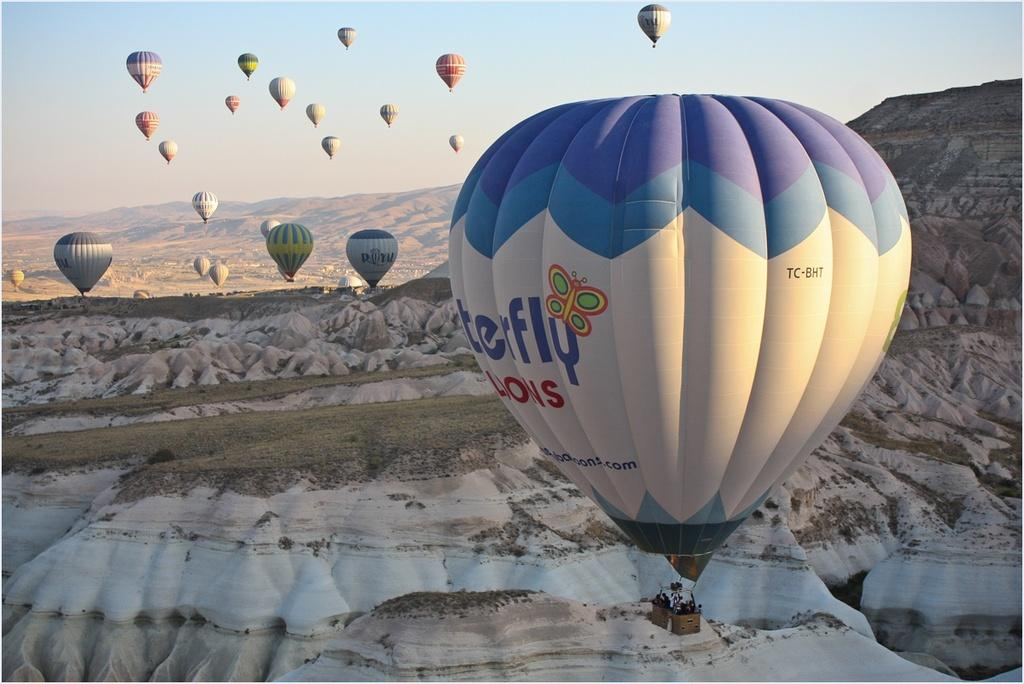What are the people in the image doing? The people in the image are in parachutes. What can be seen in the background of the image? There are mountains in the background of the image. How many times did the person in the image press the button before jumping? There is no button present in the image, and therefore no such action can be observed. 